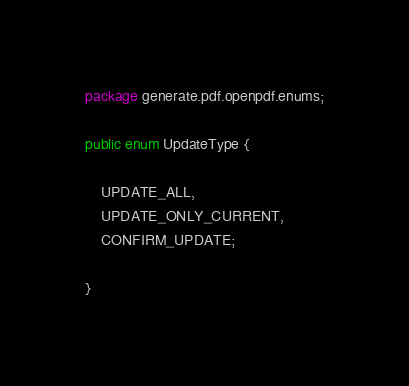Convert code to text. <code><loc_0><loc_0><loc_500><loc_500><_Java_>package generate.pdf.openpdf.enums;

public enum UpdateType {

    UPDATE_ALL,
    UPDATE_ONLY_CURRENT,
    CONFIRM_UPDATE;

}
</code> 